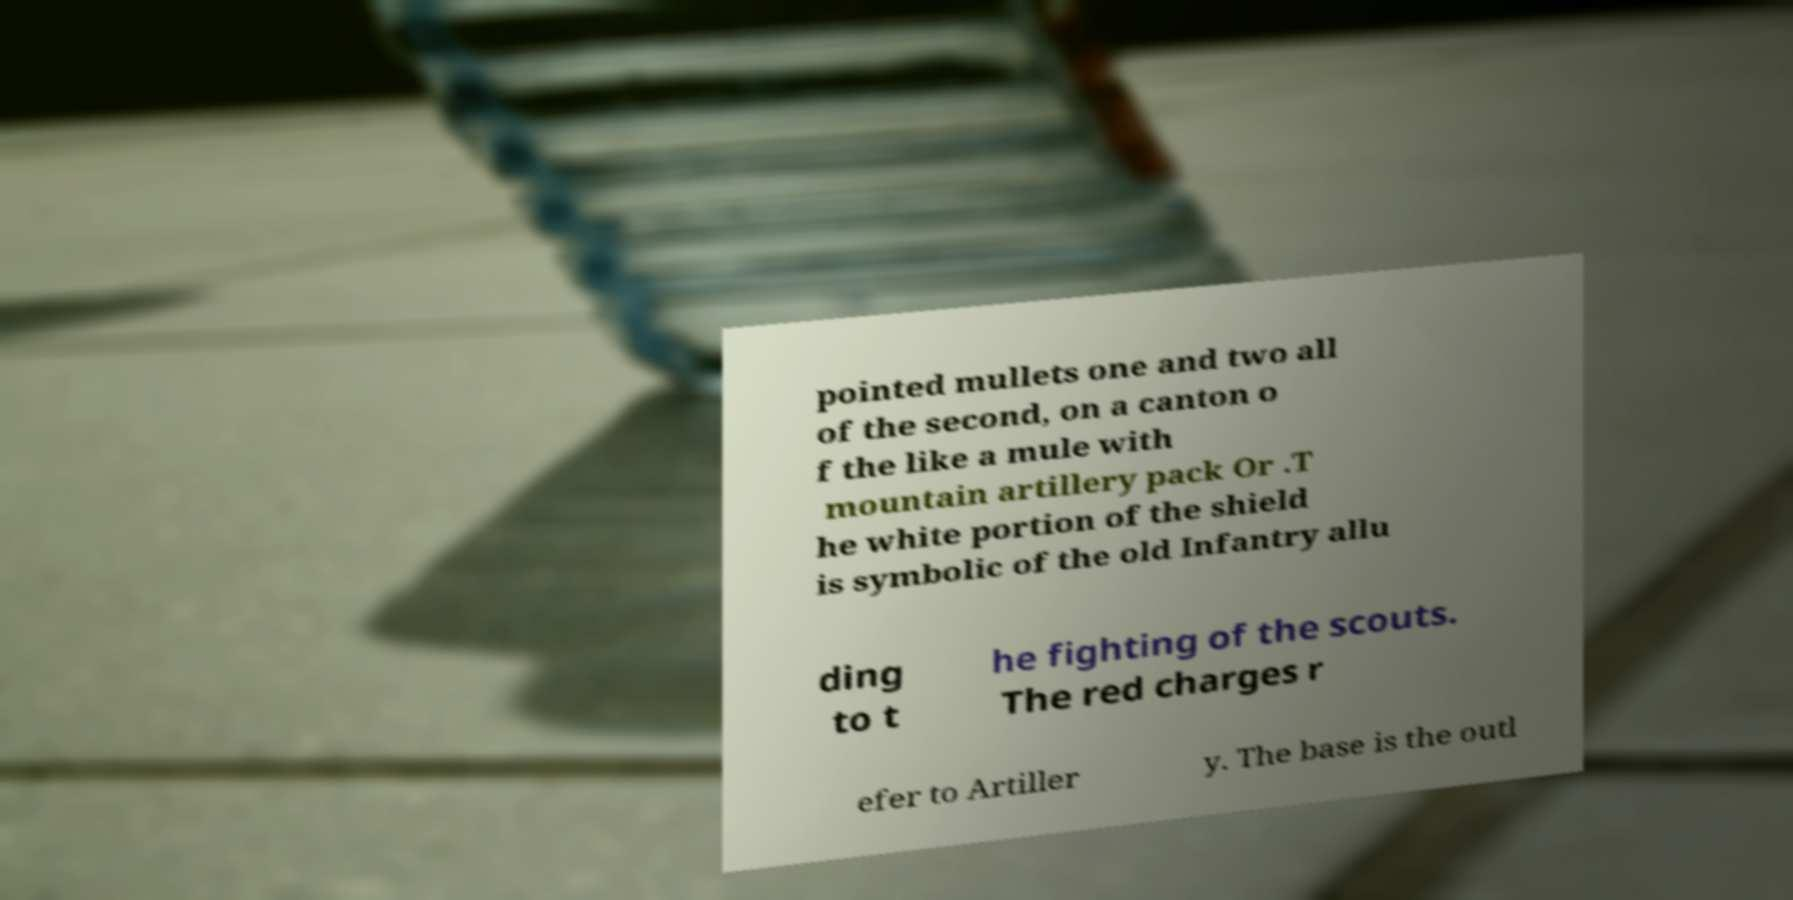Please identify and transcribe the text found in this image. pointed mullets one and two all of the second, on a canton o f the like a mule with mountain artillery pack Or .T he white portion of the shield is symbolic of the old Infantry allu ding to t he fighting of the scouts. The red charges r efer to Artiller y. The base is the outl 